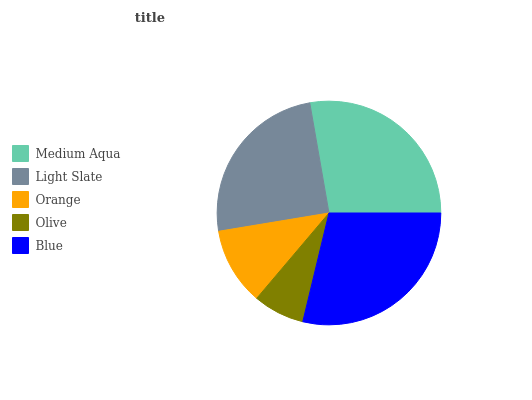Is Olive the minimum?
Answer yes or no. Yes. Is Blue the maximum?
Answer yes or no. Yes. Is Light Slate the minimum?
Answer yes or no. No. Is Light Slate the maximum?
Answer yes or no. No. Is Medium Aqua greater than Light Slate?
Answer yes or no. Yes. Is Light Slate less than Medium Aqua?
Answer yes or no. Yes. Is Light Slate greater than Medium Aqua?
Answer yes or no. No. Is Medium Aqua less than Light Slate?
Answer yes or no. No. Is Light Slate the high median?
Answer yes or no. Yes. Is Light Slate the low median?
Answer yes or no. Yes. Is Medium Aqua the high median?
Answer yes or no. No. Is Olive the low median?
Answer yes or no. No. 